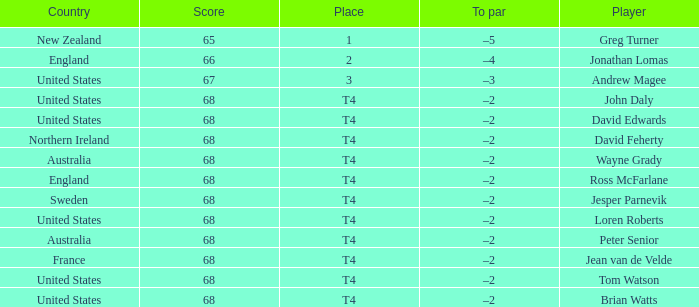Name the Place of england with a Score larger than 66? T4. Write the full table. {'header': ['Country', 'Score', 'Place', 'To par', 'Player'], 'rows': [['New Zealand', '65', '1', '–5', 'Greg Turner'], ['England', '66', '2', '–4', 'Jonathan Lomas'], ['United States', '67', '3', '–3', 'Andrew Magee'], ['United States', '68', 'T4', '–2', 'John Daly'], ['United States', '68', 'T4', '–2', 'David Edwards'], ['Northern Ireland', '68', 'T4', '–2', 'David Feherty'], ['Australia', '68', 'T4', '–2', 'Wayne Grady'], ['England', '68', 'T4', '–2', 'Ross McFarlane'], ['Sweden', '68', 'T4', '–2', 'Jesper Parnevik'], ['United States', '68', 'T4', '–2', 'Loren Roberts'], ['Australia', '68', 'T4', '–2', 'Peter Senior'], ['France', '68', 'T4', '–2', 'Jean van de Velde'], ['United States', '68', 'T4', '–2', 'Tom Watson'], ['United States', '68', 'T4', '–2', 'Brian Watts']]} 